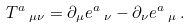Convert formula to latex. <formula><loc_0><loc_0><loc_500><loc_500>T ^ { a } \, _ { \mu \nu } = \partial _ { \mu } e ^ { a } \, _ { \nu } - \partial _ { \nu } e ^ { a } \, _ { \mu } \, .</formula> 